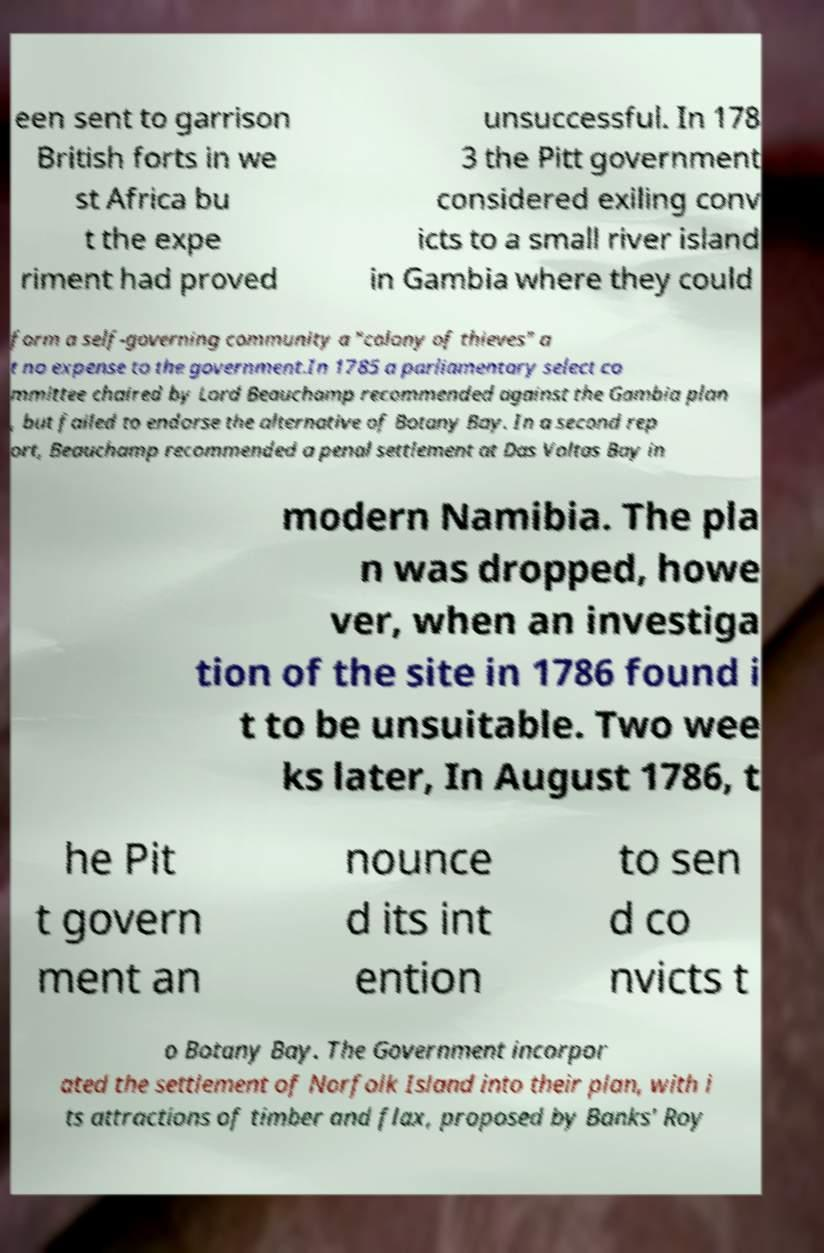Please read and relay the text visible in this image. What does it say? een sent to garrison British forts in we st Africa bu t the expe riment had proved unsuccessful. In 178 3 the Pitt government considered exiling conv icts to a small river island in Gambia where they could form a self-governing community a "colony of thieves" a t no expense to the government.In 1785 a parliamentary select co mmittee chaired by Lord Beauchamp recommended against the Gambia plan , but failed to endorse the alternative of Botany Bay. In a second rep ort, Beauchamp recommended a penal settlement at Das Voltas Bay in modern Namibia. The pla n was dropped, howe ver, when an investiga tion of the site in 1786 found i t to be unsuitable. Two wee ks later, In August 1786, t he Pit t govern ment an nounce d its int ention to sen d co nvicts t o Botany Bay. The Government incorpor ated the settlement of Norfolk Island into their plan, with i ts attractions of timber and flax, proposed by Banks' Roy 